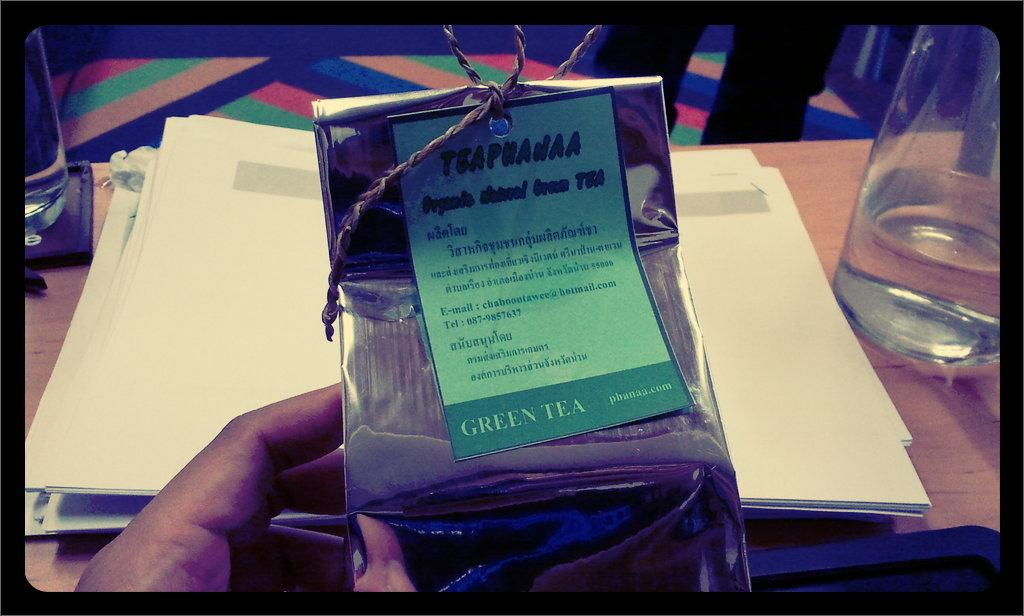<image>
Write a terse but informative summary of the picture. A silver package of Teaphana organic green tea. 